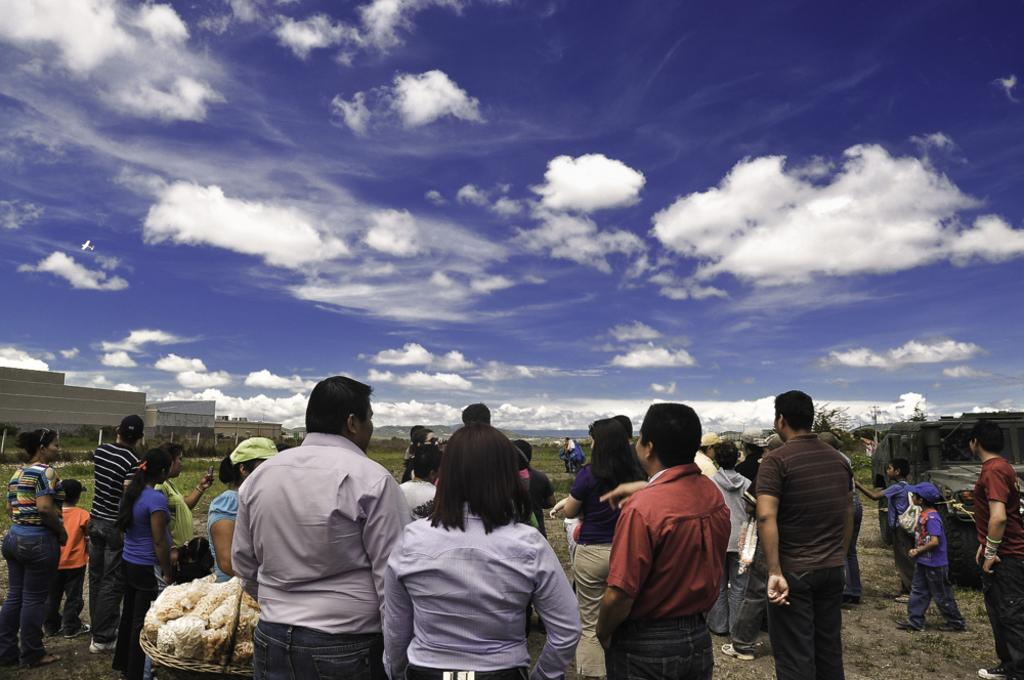What are the people in the image doing? The persons standing on the ground in the image are likely standing or walking. What structures can be seen in the image? There are buildings in the image. What type of vegetation is present in the image? There are trees in the image. What is visible in the background of the image? The sky is visible in the background of the image. What type of lace can be seen on the wing of the bird in the image? There is no bird or lace present in the image; it features persons standing on the ground, buildings, trees, and the sky. 